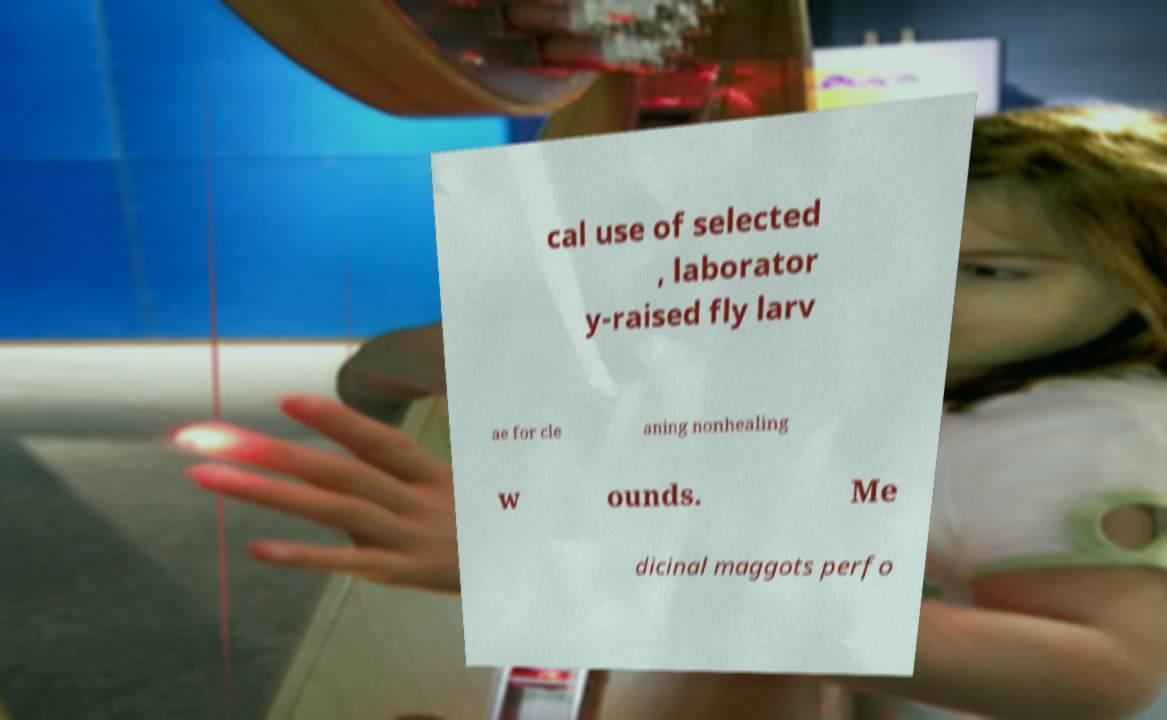Can you accurately transcribe the text from the provided image for me? cal use of selected , laborator y-raised fly larv ae for cle aning nonhealing w ounds. Me dicinal maggots perfo 